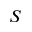<formula> <loc_0><loc_0><loc_500><loc_500>S</formula> 